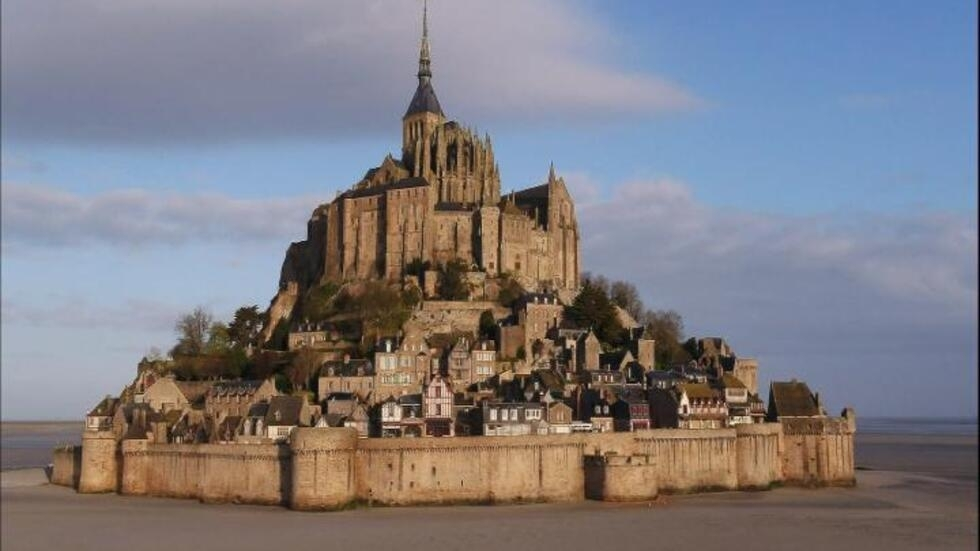Can you tell me more about the architectural styles visible in Mont St Michel? Certainly! Mont St Michel showcases a blend of architectural styles, primarily Norman and Gothic. The abbey, prominently visible in the image, features the sturdy and austere characteristics of Norman architecture with its robust structure and rounded arches. As you move upward, the Gothic elements become evident, especially in the delicate spire and the flying buttresses that add both support and beauty to the building. Each element reflects the adaptations and expansions it underwent through various periods, echoing the rich history of architectural evolution at this site. 